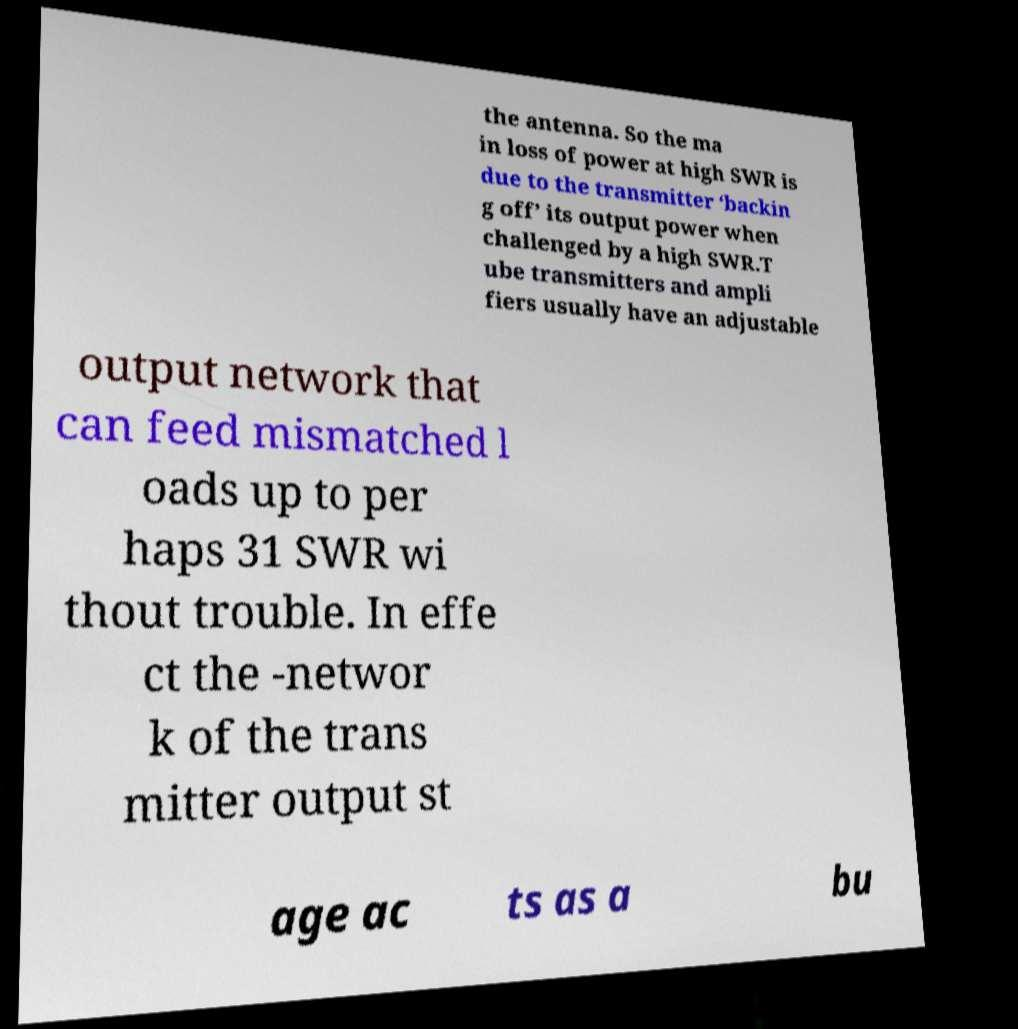Could you extract and type out the text from this image? the antenna. So the ma in loss of power at high SWR is due to the transmitter ‘backin g off’ its output power when challenged by a high SWR.T ube transmitters and ampli fiers usually have an adjustable output network that can feed mismatched l oads up to per haps 31 SWR wi thout trouble. In effe ct the -networ k of the trans mitter output st age ac ts as a bu 